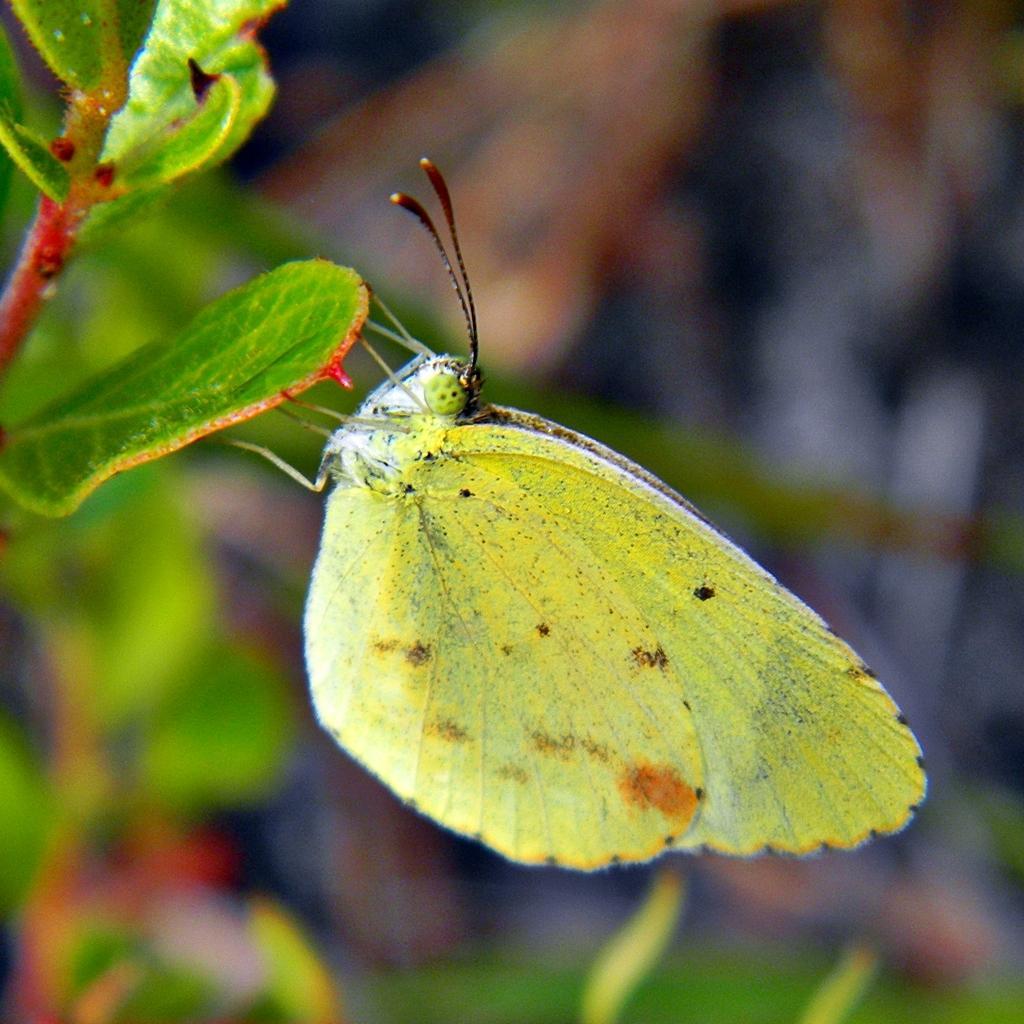Could you give a brief overview of what you see in this image? In this image there is a butterfly holding leaf of a plant. 